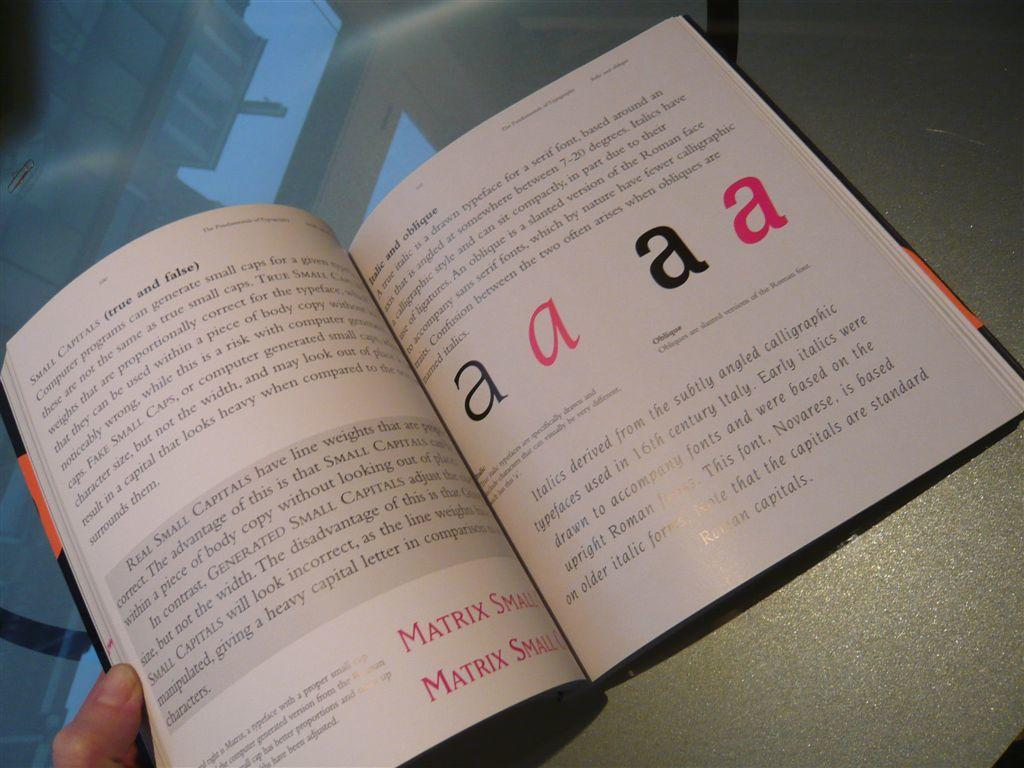<image>
Share a concise interpretation of the image provided. Book lays open on a table and says matrix small twice 